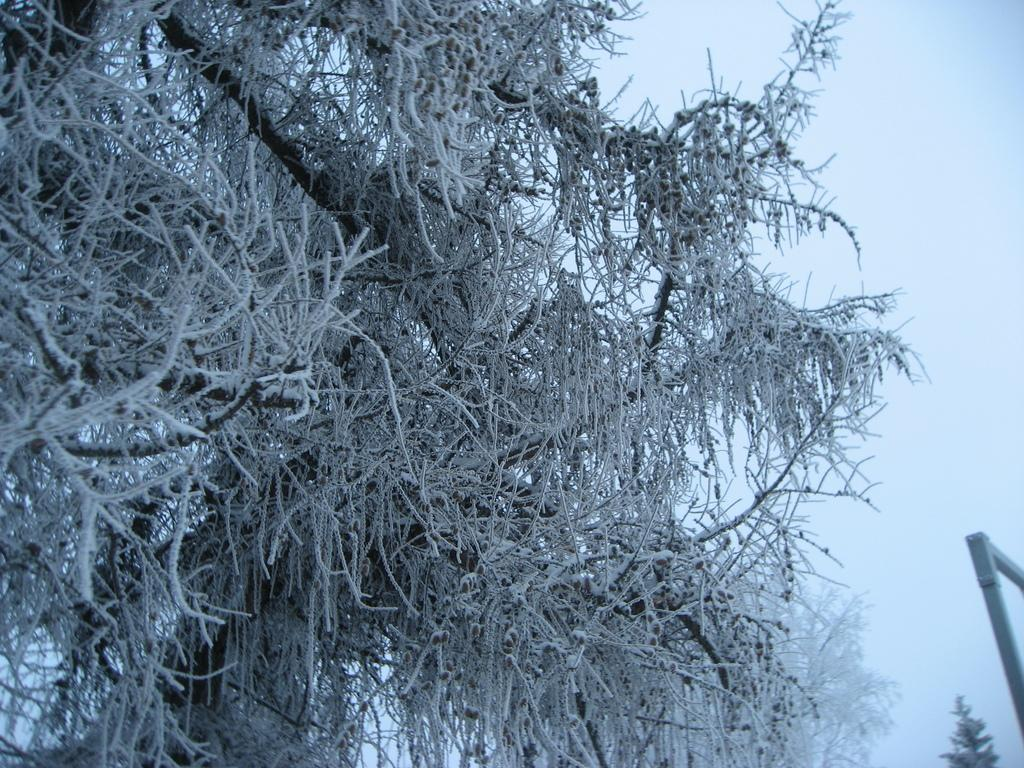What type of weather is suggested by the presence of snow in the image? The presence of snow suggests cold weather in the image. What object can be seen on the right side of the image? There is a metal rod on the right side of the image. What is visible in the background of the image? The sky is visible in the background of the image. How does the camp feel about the loss in the image? There is no camp or loss mentioned in the image; it features snow on trees and a metal rod on the right side. 